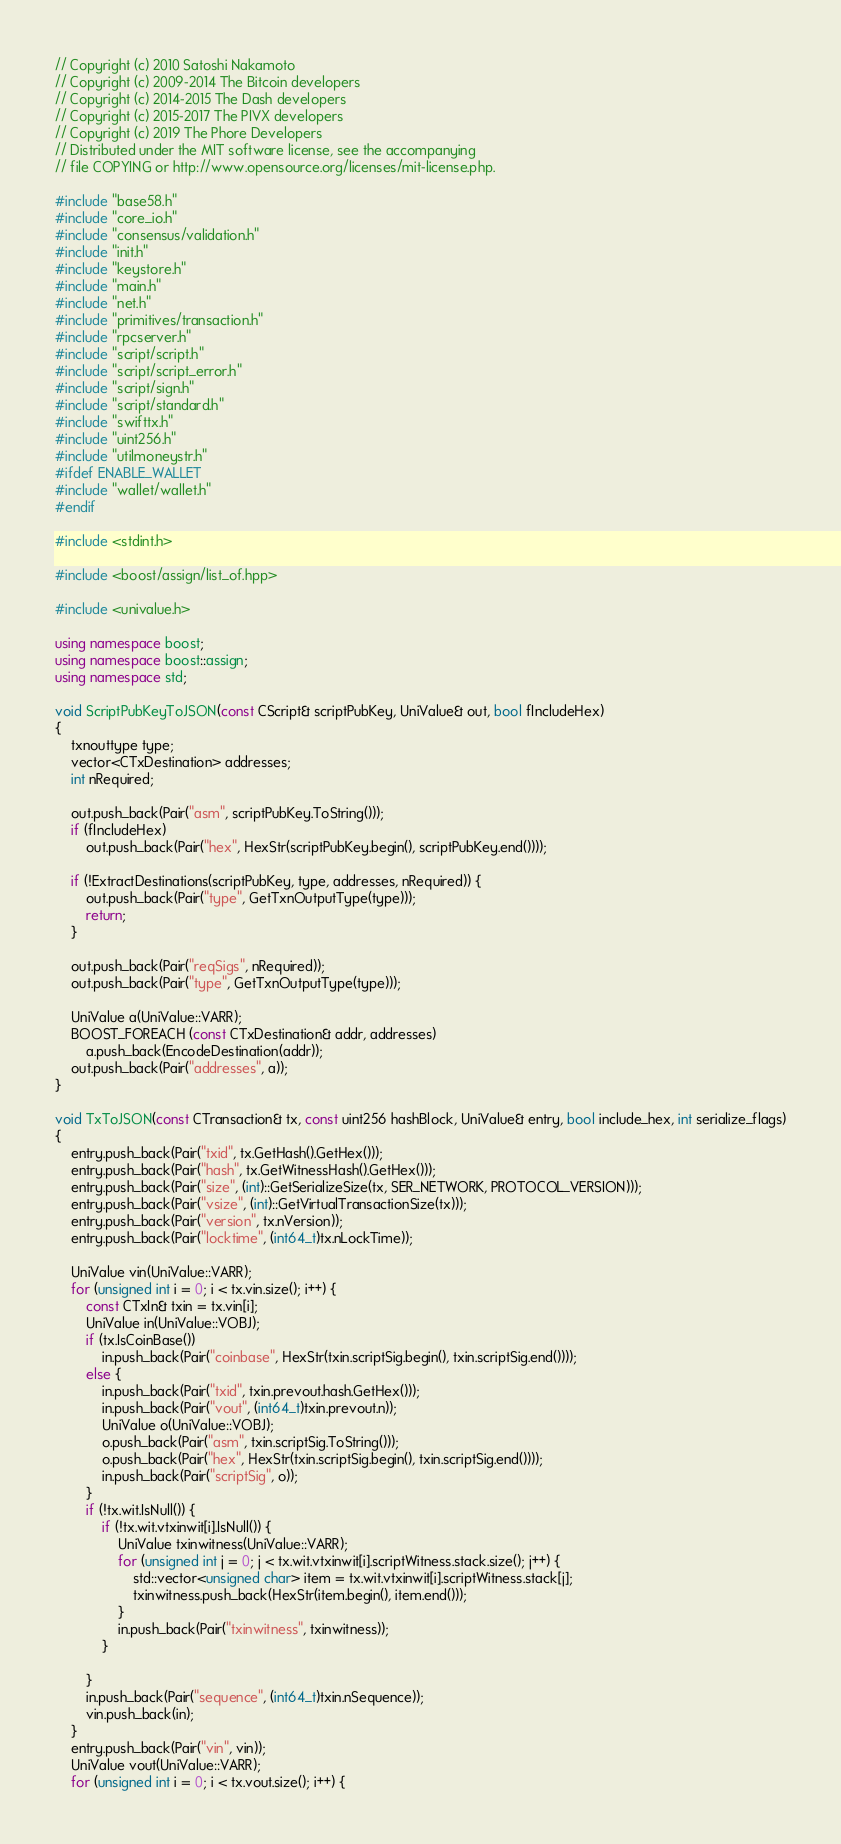<code> <loc_0><loc_0><loc_500><loc_500><_C++_>// Copyright (c) 2010 Satoshi Nakamoto
// Copyright (c) 2009-2014 The Bitcoin developers
// Copyright (c) 2014-2015 The Dash developers
// Copyright (c) 2015-2017 The PIVX developers
// Copyright (c) 2019 The Phore Developers
// Distributed under the MIT software license, see the accompanying
// file COPYING or http://www.opensource.org/licenses/mit-license.php.

#include "base58.h"
#include "core_io.h"
#include "consensus/validation.h"
#include "init.h"
#include "keystore.h"
#include "main.h"
#include "net.h"
#include "primitives/transaction.h"
#include "rpcserver.h"
#include "script/script.h"
#include "script/script_error.h"
#include "script/sign.h"
#include "script/standard.h"
#include "swifttx.h"
#include "uint256.h"
#include "utilmoneystr.h"
#ifdef ENABLE_WALLET
#include "wallet/wallet.h"
#endif

#include <stdint.h>

#include <boost/assign/list_of.hpp>

#include <univalue.h>

using namespace boost;
using namespace boost::assign;
using namespace std;

void ScriptPubKeyToJSON(const CScript& scriptPubKey, UniValue& out, bool fIncludeHex)
{
    txnouttype type;
    vector<CTxDestination> addresses;
    int nRequired;

    out.push_back(Pair("asm", scriptPubKey.ToString()));
    if (fIncludeHex)
        out.push_back(Pair("hex", HexStr(scriptPubKey.begin(), scriptPubKey.end())));

    if (!ExtractDestinations(scriptPubKey, type, addresses, nRequired)) {
        out.push_back(Pair("type", GetTxnOutputType(type)));
        return;
    }

    out.push_back(Pair("reqSigs", nRequired));
    out.push_back(Pair("type", GetTxnOutputType(type)));

    UniValue a(UniValue::VARR);
    BOOST_FOREACH (const CTxDestination& addr, addresses)
        a.push_back(EncodeDestination(addr));
    out.push_back(Pair("addresses", a));
}

void TxToJSON(const CTransaction& tx, const uint256 hashBlock, UniValue& entry, bool include_hex, int serialize_flags)
{
    entry.push_back(Pair("txid", tx.GetHash().GetHex()));
    entry.push_back(Pair("hash", tx.GetWitnessHash().GetHex()));
    entry.push_back(Pair("size", (int)::GetSerializeSize(tx, SER_NETWORK, PROTOCOL_VERSION)));
    entry.push_back(Pair("vsize", (int)::GetVirtualTransactionSize(tx)));
    entry.push_back(Pair("version", tx.nVersion));
    entry.push_back(Pair("locktime", (int64_t)tx.nLockTime));

    UniValue vin(UniValue::VARR);
    for (unsigned int i = 0; i < tx.vin.size(); i++) {
        const CTxIn& txin = tx.vin[i];
        UniValue in(UniValue::VOBJ);
        if (tx.IsCoinBase())
            in.push_back(Pair("coinbase", HexStr(txin.scriptSig.begin(), txin.scriptSig.end())));
        else {
            in.push_back(Pair("txid", txin.prevout.hash.GetHex()));
            in.push_back(Pair("vout", (int64_t)txin.prevout.n));
            UniValue o(UniValue::VOBJ);
            o.push_back(Pair("asm", txin.scriptSig.ToString()));
            o.push_back(Pair("hex", HexStr(txin.scriptSig.begin(), txin.scriptSig.end())));
            in.push_back(Pair("scriptSig", o));
        }
        if (!tx.wit.IsNull()) {
            if (!tx.wit.vtxinwit[i].IsNull()) {
                UniValue txinwitness(UniValue::VARR);
                for (unsigned int j = 0; j < tx.wit.vtxinwit[i].scriptWitness.stack.size(); j++) {
                    std::vector<unsigned char> item = tx.wit.vtxinwit[i].scriptWitness.stack[j];
                    txinwitness.push_back(HexStr(item.begin(), item.end()));
                }
                in.push_back(Pair("txinwitness", txinwitness));
            }

        }
        in.push_back(Pair("sequence", (int64_t)txin.nSequence));
        vin.push_back(in);
    }
    entry.push_back(Pair("vin", vin));
    UniValue vout(UniValue::VARR);
    for (unsigned int i = 0; i < tx.vout.size(); i++) {</code> 